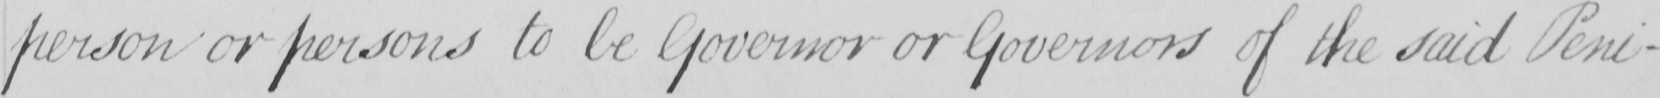What is written in this line of handwriting? person or persons to be Governor or Governors of the said Peni- 